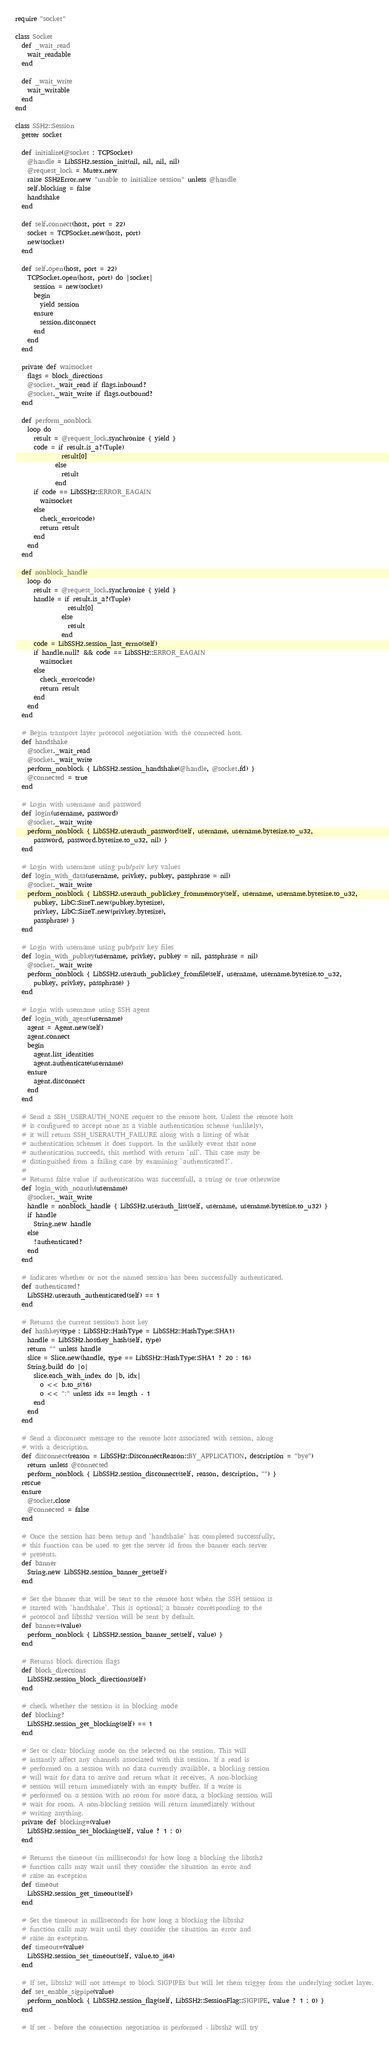<code> <loc_0><loc_0><loc_500><loc_500><_Crystal_>require "socket"

class Socket
  def _wait_read
    wait_readable
  end

  def _wait_write
    wait_writable
  end
end

class SSH2::Session
  getter socket

  def initialize(@socket : TCPSocket)
    @handle = LibSSH2.session_init(nil, nil, nil, nil)
    @request_lock = Mutex.new
    raise SSH2Error.new "unable to initialize session" unless @handle
    self.blocking = false
    handshake
  end

  def self.connect(host, port = 22)
    socket = TCPSocket.new(host, port)
    new(socket)
  end

  def self.open(host, port = 22)
    TCPSocket.open(host, port) do |socket|
      session = new(socket)
      begin
        yield session
      ensure
        session.disconnect
      end
    end
  end

  private def waitsocket
    flags = block_directions
    @socket._wait_read if flags.inbound?
    @socket._wait_write if flags.outbound?
  end

  def perform_nonblock
    loop do
      result = @request_lock.synchronize { yield }
      code = if result.is_a?(Tuple)
               result[0]
             else
               result
             end
      if code == LibSSH2::ERROR_EAGAIN
        waitsocket
      else
        check_error(code)
        return result
      end
    end
  end

  def nonblock_handle
    loop do
      result = @request_lock.synchronize { yield }
      handle = if result.is_a?(Tuple)
                 result[0]
               else
                 result
               end
      code = LibSSH2.session_last_errno(self)
      if handle.null? && code == LibSSH2::ERROR_EAGAIN
        waitsocket
      else
        check_error(code)
        return result
      end
    end
  end

  # Begin transport layer protocol negotiation with the connected host.
  def handshake
    @socket._wait_read
    @socket._wait_write
    perform_nonblock { LibSSH2.session_handshake(@handle, @socket.fd) }
    @connected = true
  end

  # Login with username and password
  def login(username, password)
    @socket._wait_write
    perform_nonblock { LibSSH2.userauth_password(self, username, username.bytesize.to_u32,
      password, password.bytesize.to_u32, nil) }
  end

  # Login with username using pub/priv key values
  def login_with_data(username, privkey, pubkey, passphrase = nil)
    @socket._wait_write
    perform_nonblock { LibSSH2.userauth_publickey_frommemory(self, username, username.bytesize.to_u32,
      pubkey, LibC::SizeT.new(pubkey.bytesize),
      privkey, LibC::SizeT.new(privkey.bytesize),
      passphrase) }
  end

  # Login with username using pub/priv key files
  def login_with_pubkey(username, privkey, pubkey = nil, passphrase = nil)
    @socket._wait_write
    perform_nonblock { LibSSH2.userauth_publickey_fromfile(self, username, username.bytesize.to_u32,
      pubkey, privkey, passphrase) }
  end

  # Login with username using SSH agent
  def login_with_agent(username)
    agent = Agent.new(self)
    agent.connect
    begin
      agent.list_identities
      agent.authenticate(username)
    ensure
      agent.disconnect
    end
  end

  # Send a SSH_USERAUTH_NONE request to the remote host. Unless the remote host
  # is configured to accept none as a viable authentication scheme (unlikely),
  # it will return SSH_USERAUTH_FAILURE along with a listing of what
  # authentication schemes it does support. In the unlikely event that none
  # authentication succeeds, this method with return `nil`. This case may be
  # distinguished from a failing case by examining `authenticated?`.
  #
  # Returns false value if authentication was successfull, a string or true otherwise
  def login_with_noauth(username)
    @socket._wait_write
    handle = nonblock_handle { LibSSH2.userauth_list(self, username, username.bytesize.to_u32) }
    if handle
      String.new handle
    else
      !authenticated?
    end
  end

  # Indicates whether or not the named session has been successfully authenticated.
  def authenticated?
    LibSSH2.userauth_authenticated(self) == 1
  end

  # Returns the current session's host key
  def hashkey(type : LibSSH2::HashType = LibSSH2::HashType::SHA1)
    handle = LibSSH2.hostkey_hash(self, type)
    return "" unless handle
    slice = Slice.new(handle, type == LibSSH2::HashType::SHA1 ? 20 : 16)
    String.build do |o|
      slice.each_with_index do |b, idx|
        o << b.to_s(16)
        o << ":" unless idx == length - 1
      end
    end
  end

  # Send a disconnect message to the remote host associated with session, along
  # with a description.
  def disconnect(reason = LibSSH2::DisconnectReason::BY_APPLICATION, description = "bye")
    return unless @connected
    perform_nonblock { LibSSH2.session_disconnect(self, reason, description, "") }
  rescue
  ensure
    @socket.close
    @connected = false
  end

  # Once the session has been setup and `handshake` has completed successfully,
  # this function can be used to get the server id from the banner each server
  # presents.
  def banner
    String.new LibSSH2.session_banner_get(self)
  end

  # Set the banner that will be sent to the remote host when the SSH session is
  # started with `handshake`. This is optional; a banner corresponding to the
  # protocol and libssh2 version will be sent by default.
  def banner=(value)
    perform_nonblock { LibSSH2.session_banner_set(self, value) }
  end

  # Returns block direction flags
  def block_directions
    LibSSH2.session_block_directions(self)
  end

  # check whether the session is in blocking mode
  def blocking?
    LibSSH2.session_get_blocking(self) == 1
  end

  # Set or clear blocking mode on the selected on the session. This will
  # instantly affect any channels associated with this session. If a read is
  # performed on a session with no data currently available, a blocking session
  # will wait for data to arrive and return what it receives. A non-blocking
  # session will return immediately with an empty buffer. If a write is
  # performed on a session with no room for more data, a blocking session will
  # wait for room. A non-blocking session will return immediately without
  # writing anything.
  private def blocking=(value)
    LibSSH2.session_set_blocking(self, value ? 1 : 0)
  end

  # Returns the timeout (in milliseconds) for how long a blocking the libssh2
  # function calls may wait until they consider the situation an error and
  # raise an exception
  def timeout
    LibSSH2.session_get_timeout(self)
  end

  # Set the timeout in milliseconds for how long a blocking the libssh2
  # function calls may wait until they consider the situation an error and
  # raise an exception.
  def timeout=(value)
    LibSSH2.session_set_timeout(self, value.to_i64)
  end

  # If set, libssh2 will not attempt to block SIGPIPEs but will let them trigger from the underlying socket layer.
  def set_enable_sigpipe(value)
    perform_nonblock { LibSSH2.session_flag(self, LibSSH2::SessionFlag::SIGPIPE, value ? 1 : 0) }
  end

  # If set - before the connection negotiation is performed - libssh2 will try</code> 